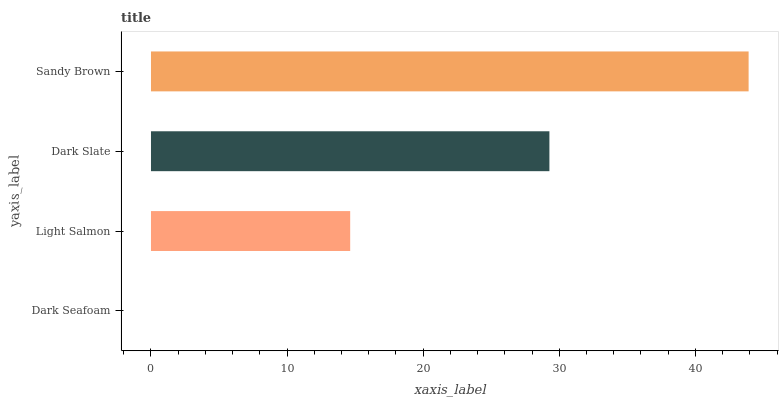Is Dark Seafoam the minimum?
Answer yes or no. Yes. Is Sandy Brown the maximum?
Answer yes or no. Yes. Is Light Salmon the minimum?
Answer yes or no. No. Is Light Salmon the maximum?
Answer yes or no. No. Is Light Salmon greater than Dark Seafoam?
Answer yes or no. Yes. Is Dark Seafoam less than Light Salmon?
Answer yes or no. Yes. Is Dark Seafoam greater than Light Salmon?
Answer yes or no. No. Is Light Salmon less than Dark Seafoam?
Answer yes or no. No. Is Dark Slate the high median?
Answer yes or no. Yes. Is Light Salmon the low median?
Answer yes or no. Yes. Is Light Salmon the high median?
Answer yes or no. No. Is Dark Seafoam the low median?
Answer yes or no. No. 